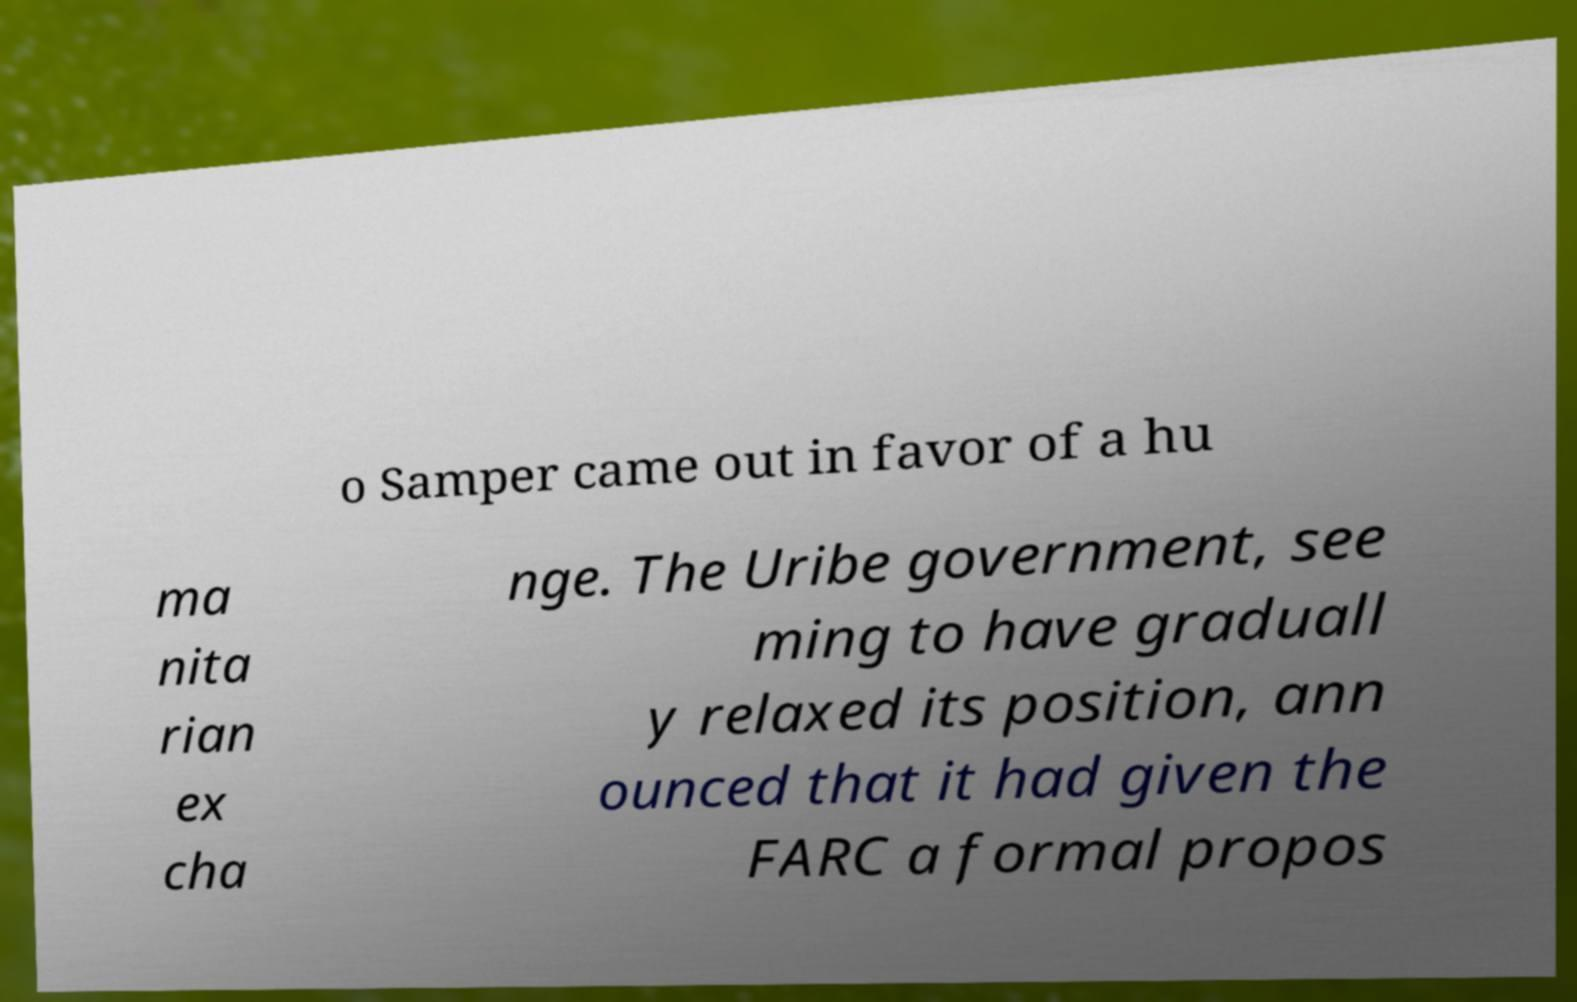Could you extract and type out the text from this image? o Samper came out in favor of a hu ma nita rian ex cha nge. The Uribe government, see ming to have graduall y relaxed its position, ann ounced that it had given the FARC a formal propos 